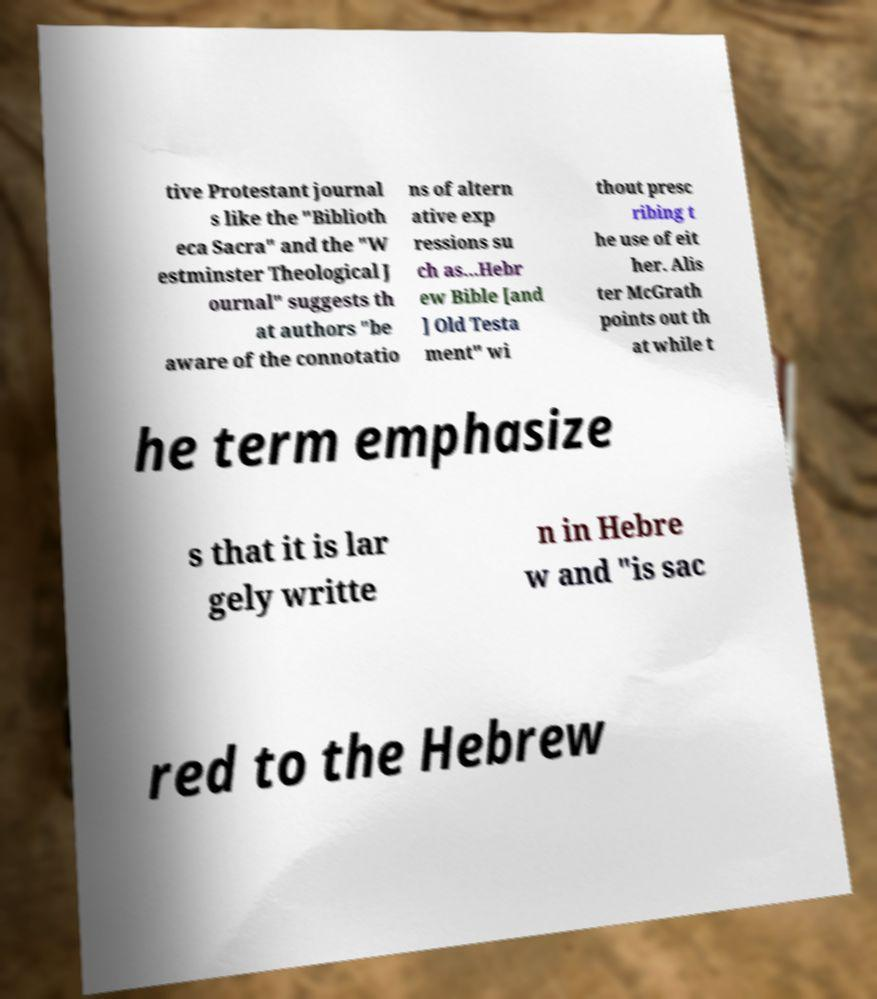What messages or text are displayed in this image? I need them in a readable, typed format. tive Protestant journal s like the "Biblioth eca Sacra" and the "W estminster Theological J ournal" suggests th at authors "be aware of the connotatio ns of altern ative exp ressions su ch as...Hebr ew Bible [and ] Old Testa ment" wi thout presc ribing t he use of eit her. Alis ter McGrath points out th at while t he term emphasize s that it is lar gely writte n in Hebre w and "is sac red to the Hebrew 